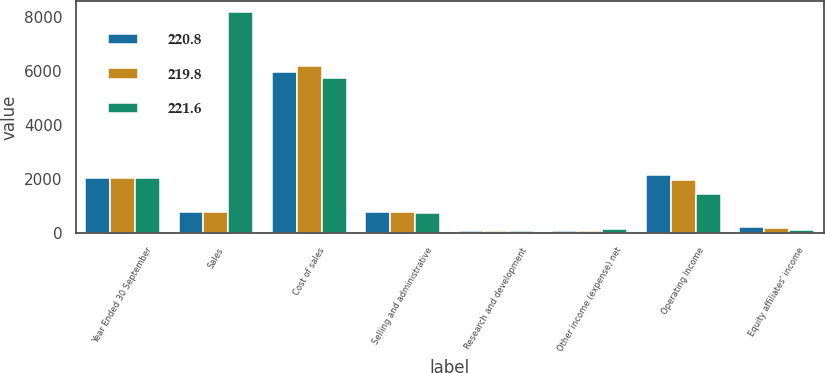<chart> <loc_0><loc_0><loc_500><loc_500><stacked_bar_chart><ecel><fcel>Year Ended 30 September<fcel>Sales<fcel>Cost of sales<fcel>Selling and administrative<fcel>Research and development<fcel>Other income (expense) net<fcel>Operating Income<fcel>Equity affiliates' income<nl><fcel>220.8<fcel>2019<fcel>755.4<fcel>5975.5<fcel>750<fcel>72.9<fcel>49.3<fcel>2144.4<fcel>215.4<nl><fcel>219.8<fcel>2018<fcel>755.4<fcel>6189.5<fcel>760.8<fcel>64.5<fcel>50.2<fcel>1965.6<fcel>174.8<nl><fcel>221.6<fcel>2017<fcel>8187.6<fcel>5751.5<fcel>713.5<fcel>57.6<fcel>121<fcel>1440<fcel>80.1<nl></chart> 